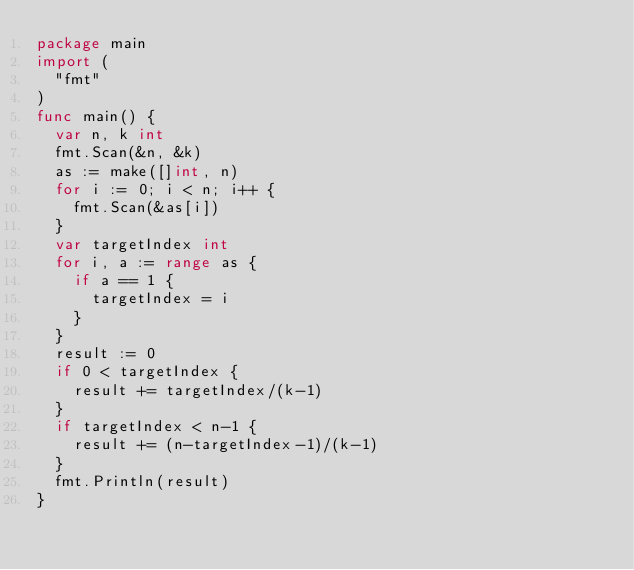<code> <loc_0><loc_0><loc_500><loc_500><_Go_>package main
import (
  "fmt"
)
func main() {
  var n, k int
  fmt.Scan(&n, &k)
  as := make([]int, n)
  for i := 0; i < n; i++ {
    fmt.Scan(&as[i])
  }
  var targetIndex int
  for i, a := range as {
    if a == 1 {
      targetIndex = i
    }
  }
  result := 0
  if 0 < targetIndex {
    result += targetIndex/(k-1)
  }
  if targetIndex < n-1 {
    result += (n-targetIndex-1)/(k-1)
  }
  fmt.Println(result)
}</code> 